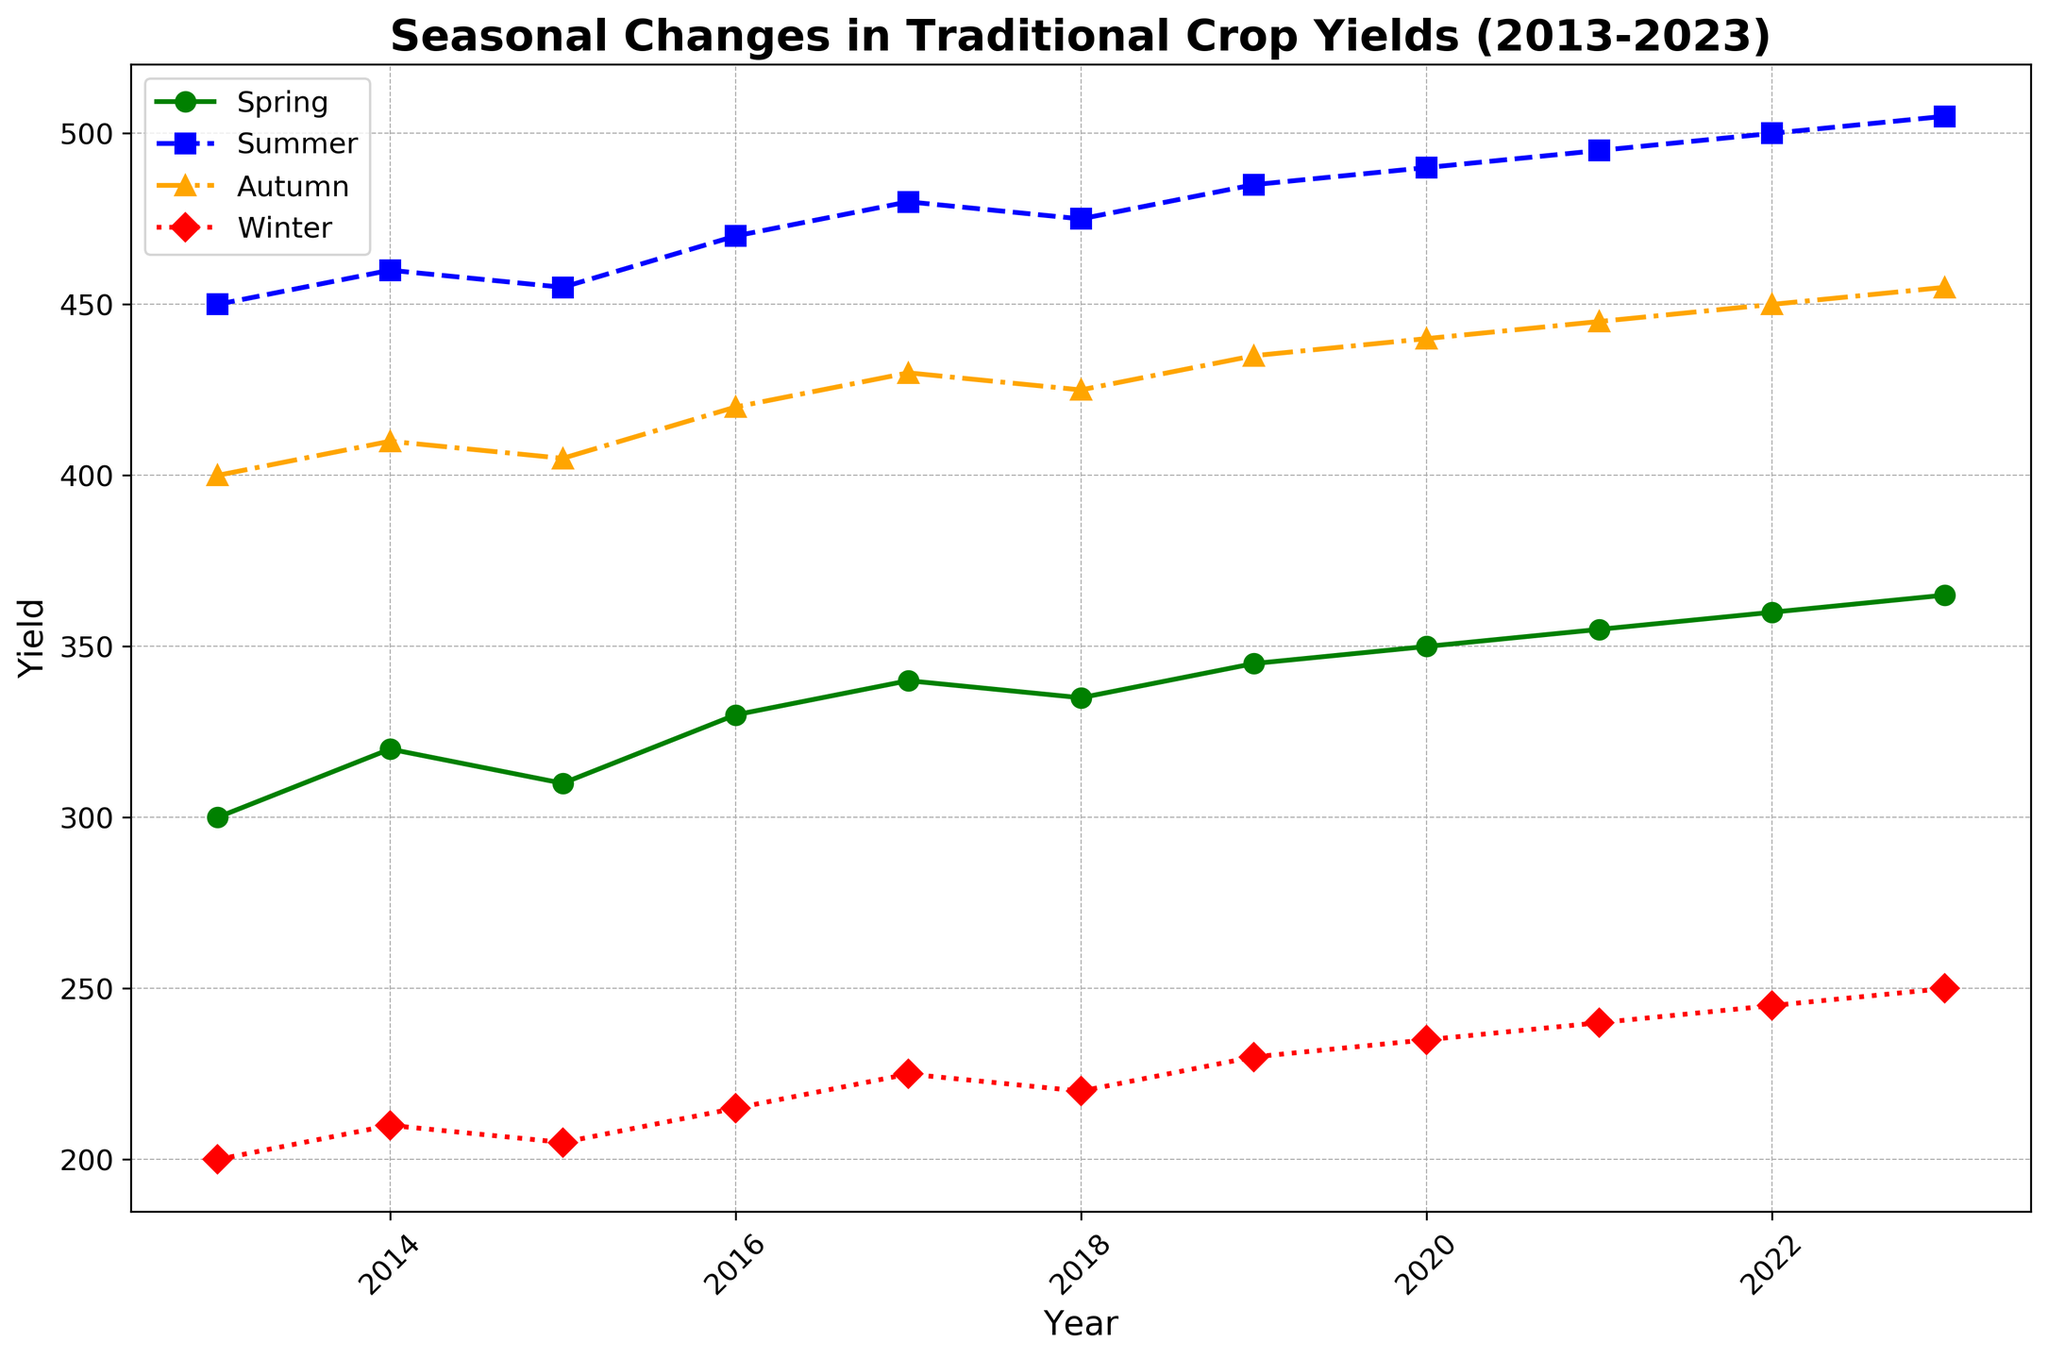How much did the crop yield increase in Spring from 2013 to 2023? To find this, subtract the Spring yield of 2013 (300) from the Spring yield of 2023 (365): 365 - 300 = 65.
Answer: 65 Which season had the highest yield in 2020? Look at the yield values for 2020 and identify the highest one among the seasons. Summer had the highest yield with 490.
Answer: Summer In which year did the Winter yield first surpass 220? Find the year where the Winter yield first exceeded 220. Winter yield was greater than 220 starting in 2017.
Answer: 2017 What is the average yield for Autumn across all years? Sum all the Autumn yields: (400 + 410 + 405 + 420 + 430 + 425 + 435 + 440 + 445 + 450 + 455) = 4515. Then divide by the number of years (11): 4515 / 11 = 410.
Answer: 410 By how much did the Summer yield increase from 2016 to 2023? Subtract the Summer yield of 2016 (470) from the Summer yield of 2023 (505): 505 - 470 = 35.
Answer: 35 Which season shows the most consistent yield pattern, based on the visual inspection of the plot? On visual inspection, the season with the least variation and most consistent increase appears to be Winter, as it shows a steady rise without significant fluctuations.
Answer: Winter What is the difference in crop yield between Summer and Winter in 2021? Subtract the Winter yield in 2021 (240) from the Summer yield in 2021 (495): 495 - 240 = 255.
Answer: 255 Identify the year when Spring yield was equal to 335. Locate the year where Spring yield is 335. This is found in the year 2018.
Answer: 2018 What is the cumulative yield for Spring, Autumn, and Winter in 2019? Sum the yields for Spring (345), Autumn (435), and Winter (230) in 2019: 345 + 435 + 230 = 1010.
Answer: 1010 Which season had the largest absolute increase in yield from 2018 to 2020? Calculate the yield increase for each season: 
Spring: 350 - 335 = 15 
Summer: 490 - 475 = 15 
Autumn: 440 - 425 = 15 
Winter: 235 - 220 = 15 
Since all increases are equal, any season can be the answer.
Answer: Spring, Summer, Autumn, or Winter 